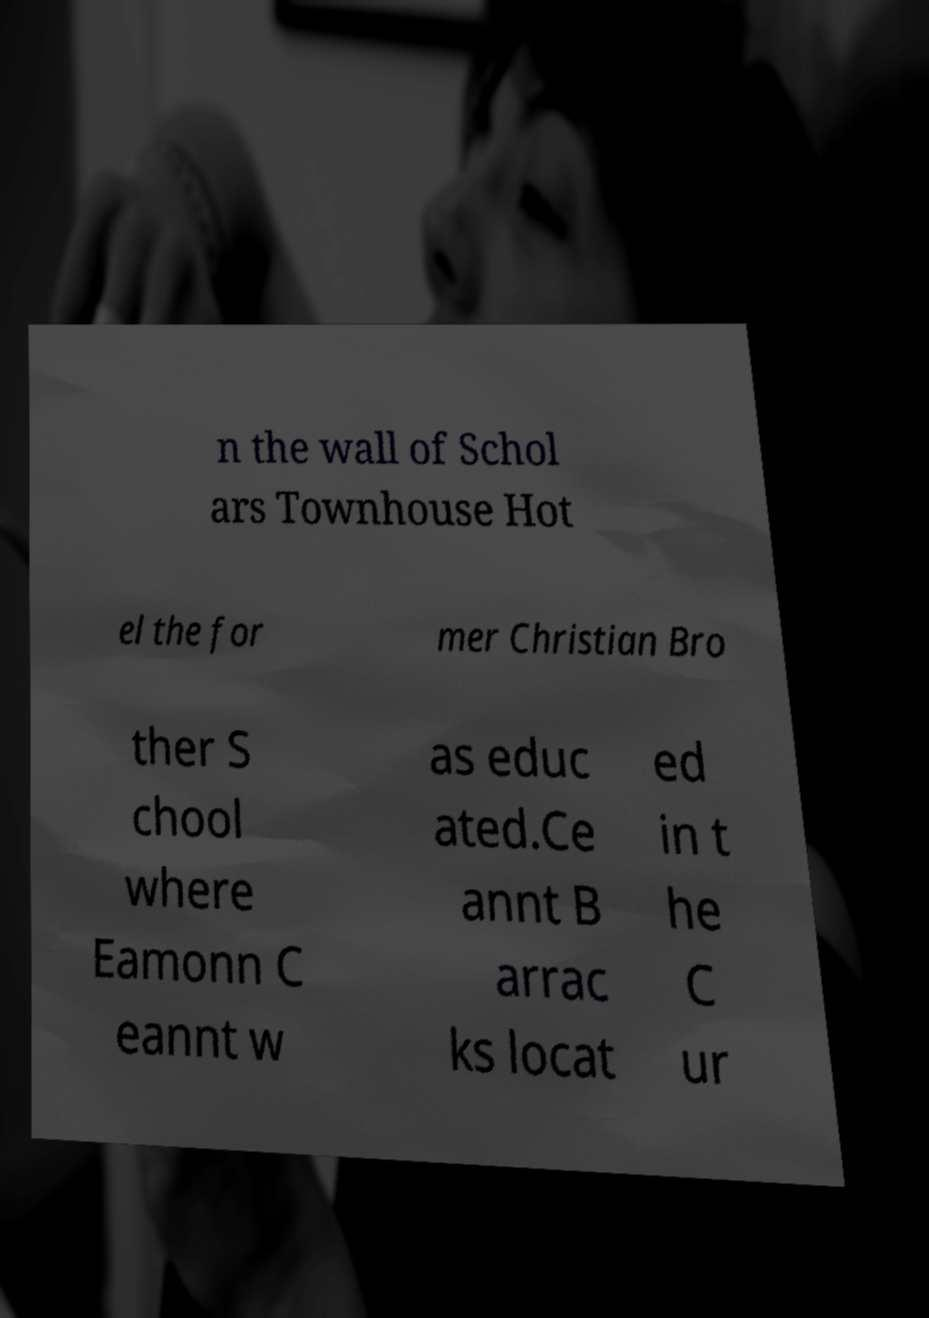Could you assist in decoding the text presented in this image and type it out clearly? n the wall of Schol ars Townhouse Hot el the for mer Christian Bro ther S chool where Eamonn C eannt w as educ ated.Ce annt B arrac ks locat ed in t he C ur 